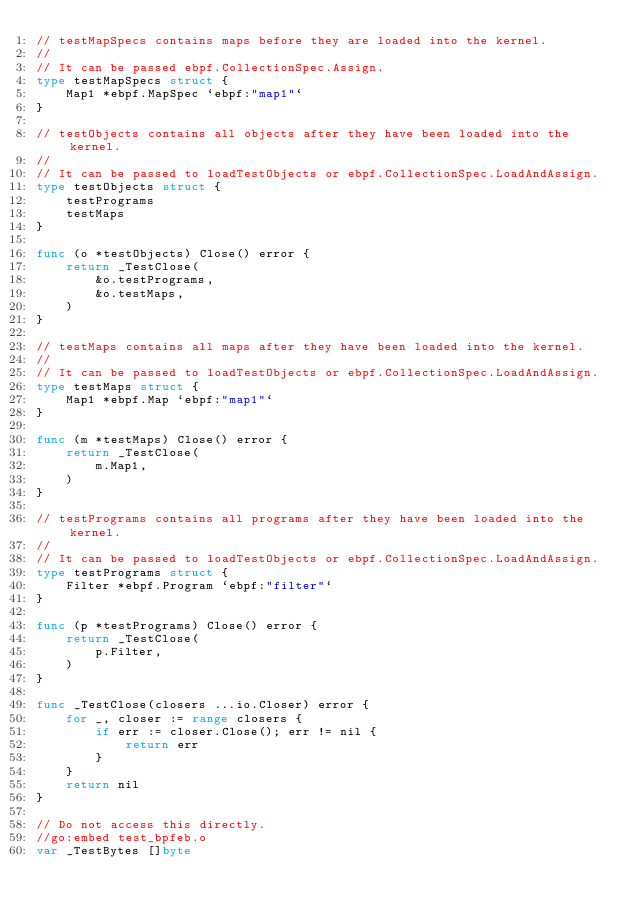<code> <loc_0><loc_0><loc_500><loc_500><_Go_>// testMapSpecs contains maps before they are loaded into the kernel.
//
// It can be passed ebpf.CollectionSpec.Assign.
type testMapSpecs struct {
	Map1 *ebpf.MapSpec `ebpf:"map1"`
}

// testObjects contains all objects after they have been loaded into the kernel.
//
// It can be passed to loadTestObjects or ebpf.CollectionSpec.LoadAndAssign.
type testObjects struct {
	testPrograms
	testMaps
}

func (o *testObjects) Close() error {
	return _TestClose(
		&o.testPrograms,
		&o.testMaps,
	)
}

// testMaps contains all maps after they have been loaded into the kernel.
//
// It can be passed to loadTestObjects or ebpf.CollectionSpec.LoadAndAssign.
type testMaps struct {
	Map1 *ebpf.Map `ebpf:"map1"`
}

func (m *testMaps) Close() error {
	return _TestClose(
		m.Map1,
	)
}

// testPrograms contains all programs after they have been loaded into the kernel.
//
// It can be passed to loadTestObjects or ebpf.CollectionSpec.LoadAndAssign.
type testPrograms struct {
	Filter *ebpf.Program `ebpf:"filter"`
}

func (p *testPrograms) Close() error {
	return _TestClose(
		p.Filter,
	)
}

func _TestClose(closers ...io.Closer) error {
	for _, closer := range closers {
		if err := closer.Close(); err != nil {
			return err
		}
	}
	return nil
}

// Do not access this directly.
//go:embed test_bpfeb.o
var _TestBytes []byte
</code> 